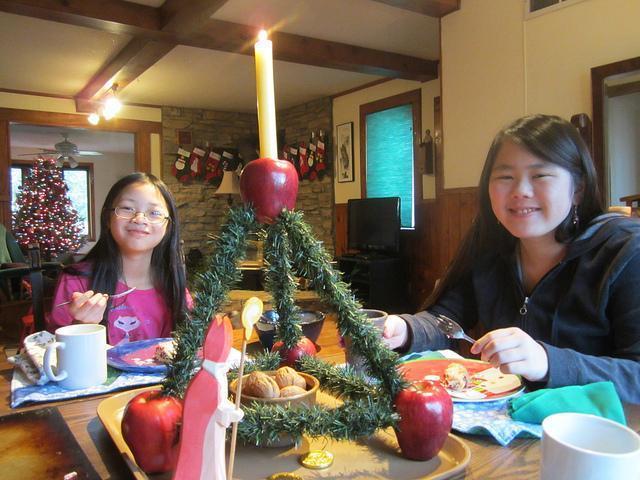How many dining tables can you see?
Give a very brief answer. 2. How many cups are in the photo?
Give a very brief answer. 2. How many apples are in the picture?
Give a very brief answer. 3. How many people can you see?
Give a very brief answer. 2. 